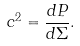Convert formula to latex. <formula><loc_0><loc_0><loc_500><loc_500>c ^ { 2 } = \frac { d P } { d \Sigma } .</formula> 